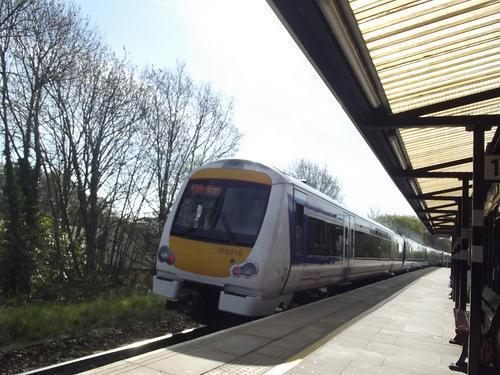How many benches can you see?
Give a very brief answer. 1. How many headlights are on front?
Give a very brief answer. 2. 